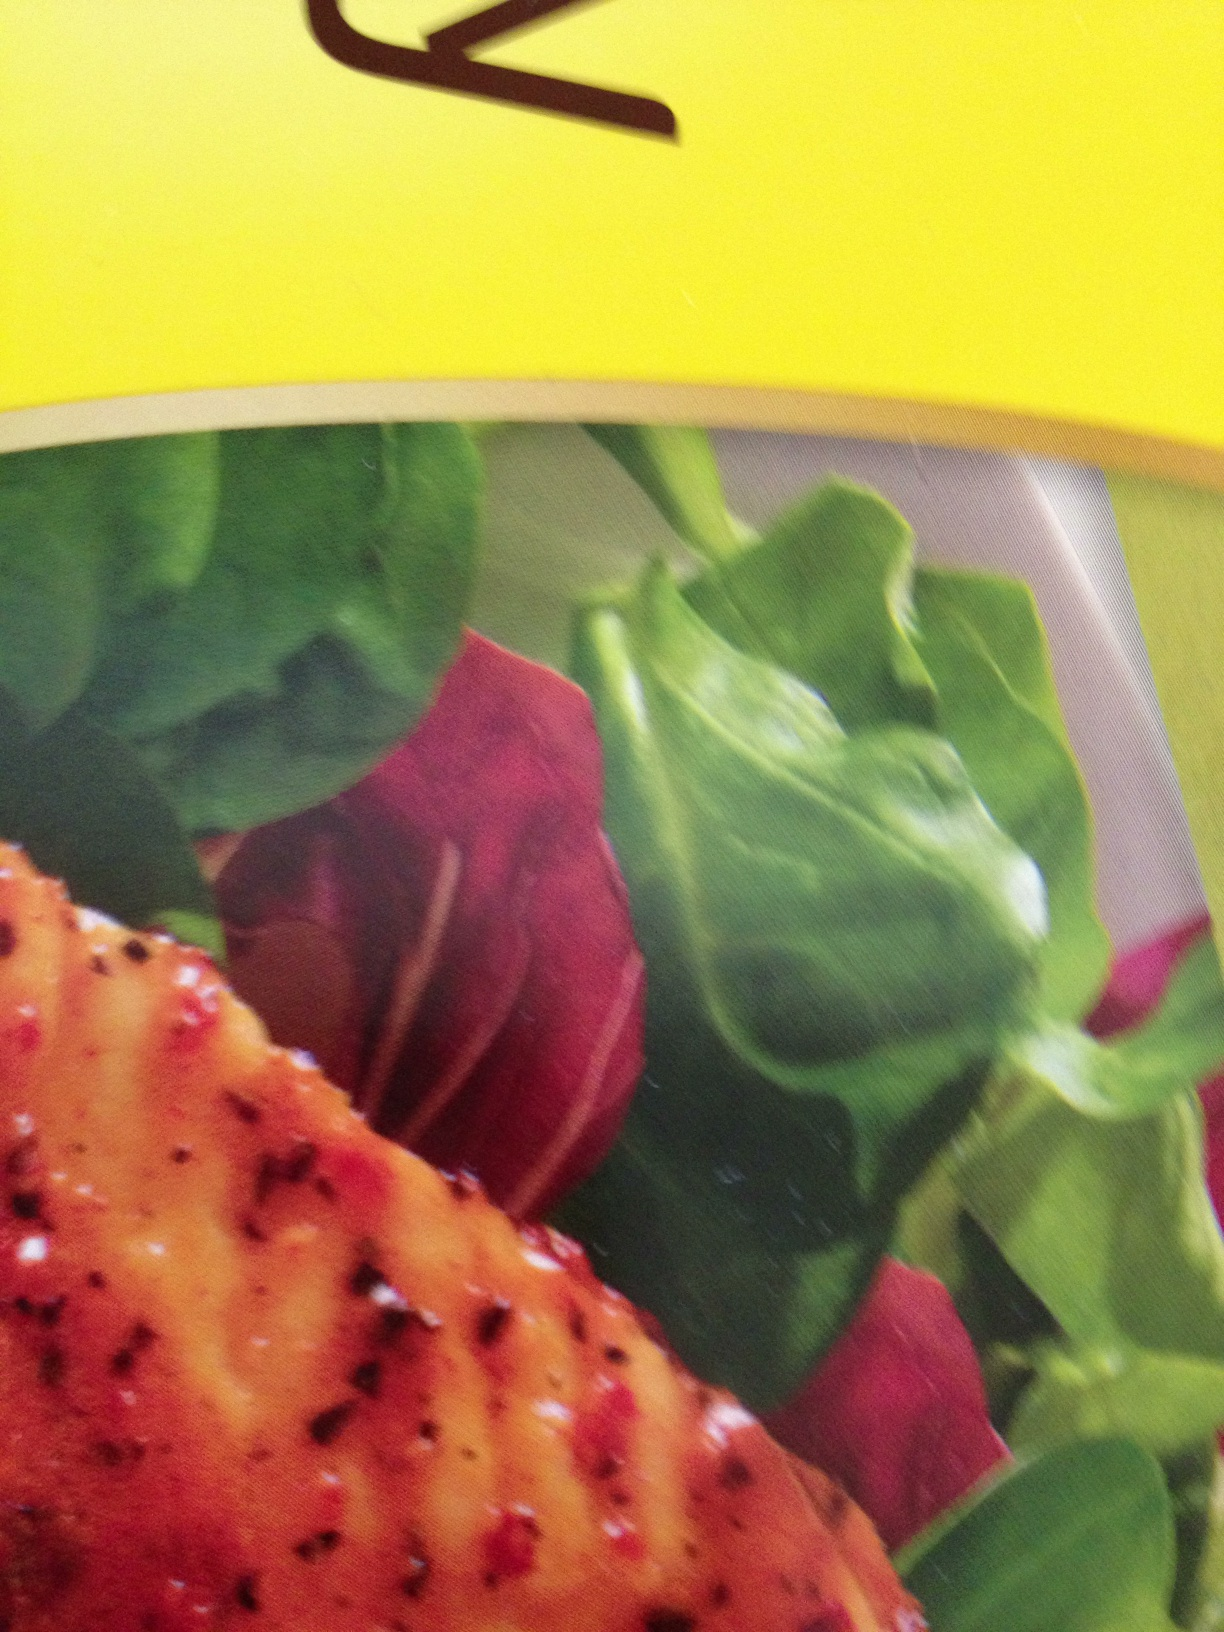Let's get creative! If this dish could talk, what story would it tell? If this dish could talk, it might tell the tale of a journey across different culinary traditions. It would speak of herbs and spices sourced from distant lands, blended masterfully to infuse the meat with layers of flavor. The fresh greens would whisper tales of gardens bathed in sunlight, while the deep red beets would share stories of being nurtured in rich, fertile soil. Together, they create a narrative of craftsmanship, care, and a love for vibrant, wholesome food. 